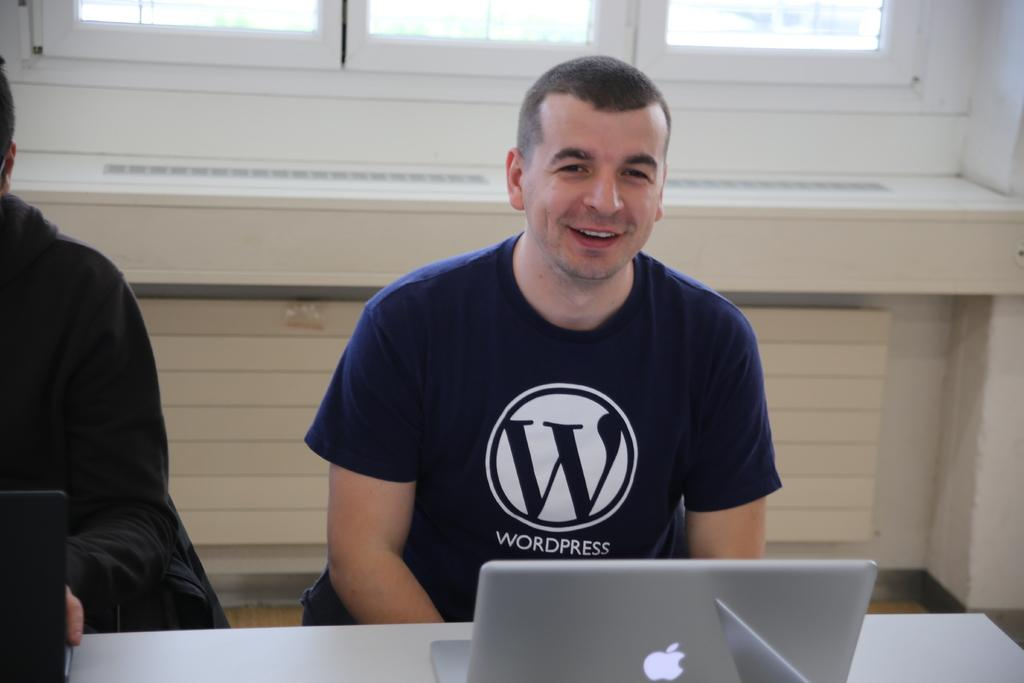How many people are in the image? There are two people sitting in the center of the image. What is in front of the people? There is a table in front of the people. What objects are on the table? Laptops are placed on the table. What can be seen in the background of the image? There is a window and a wall in the background of the image. Where is the donkey located in the image? There is no donkey present in the image. What type of car can be seen driving through the window in the image? There is no car visible through the window in the image. 